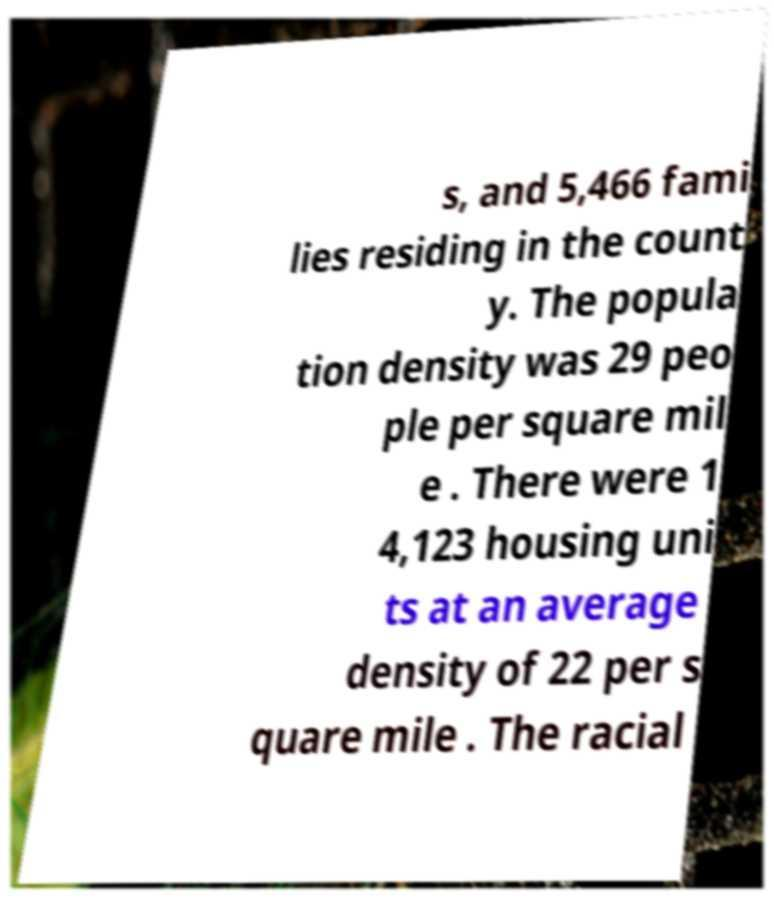What messages or text are displayed in this image? I need them in a readable, typed format. s, and 5,466 fami lies residing in the count y. The popula tion density was 29 peo ple per square mil e . There were 1 4,123 housing uni ts at an average density of 22 per s quare mile . The racial 